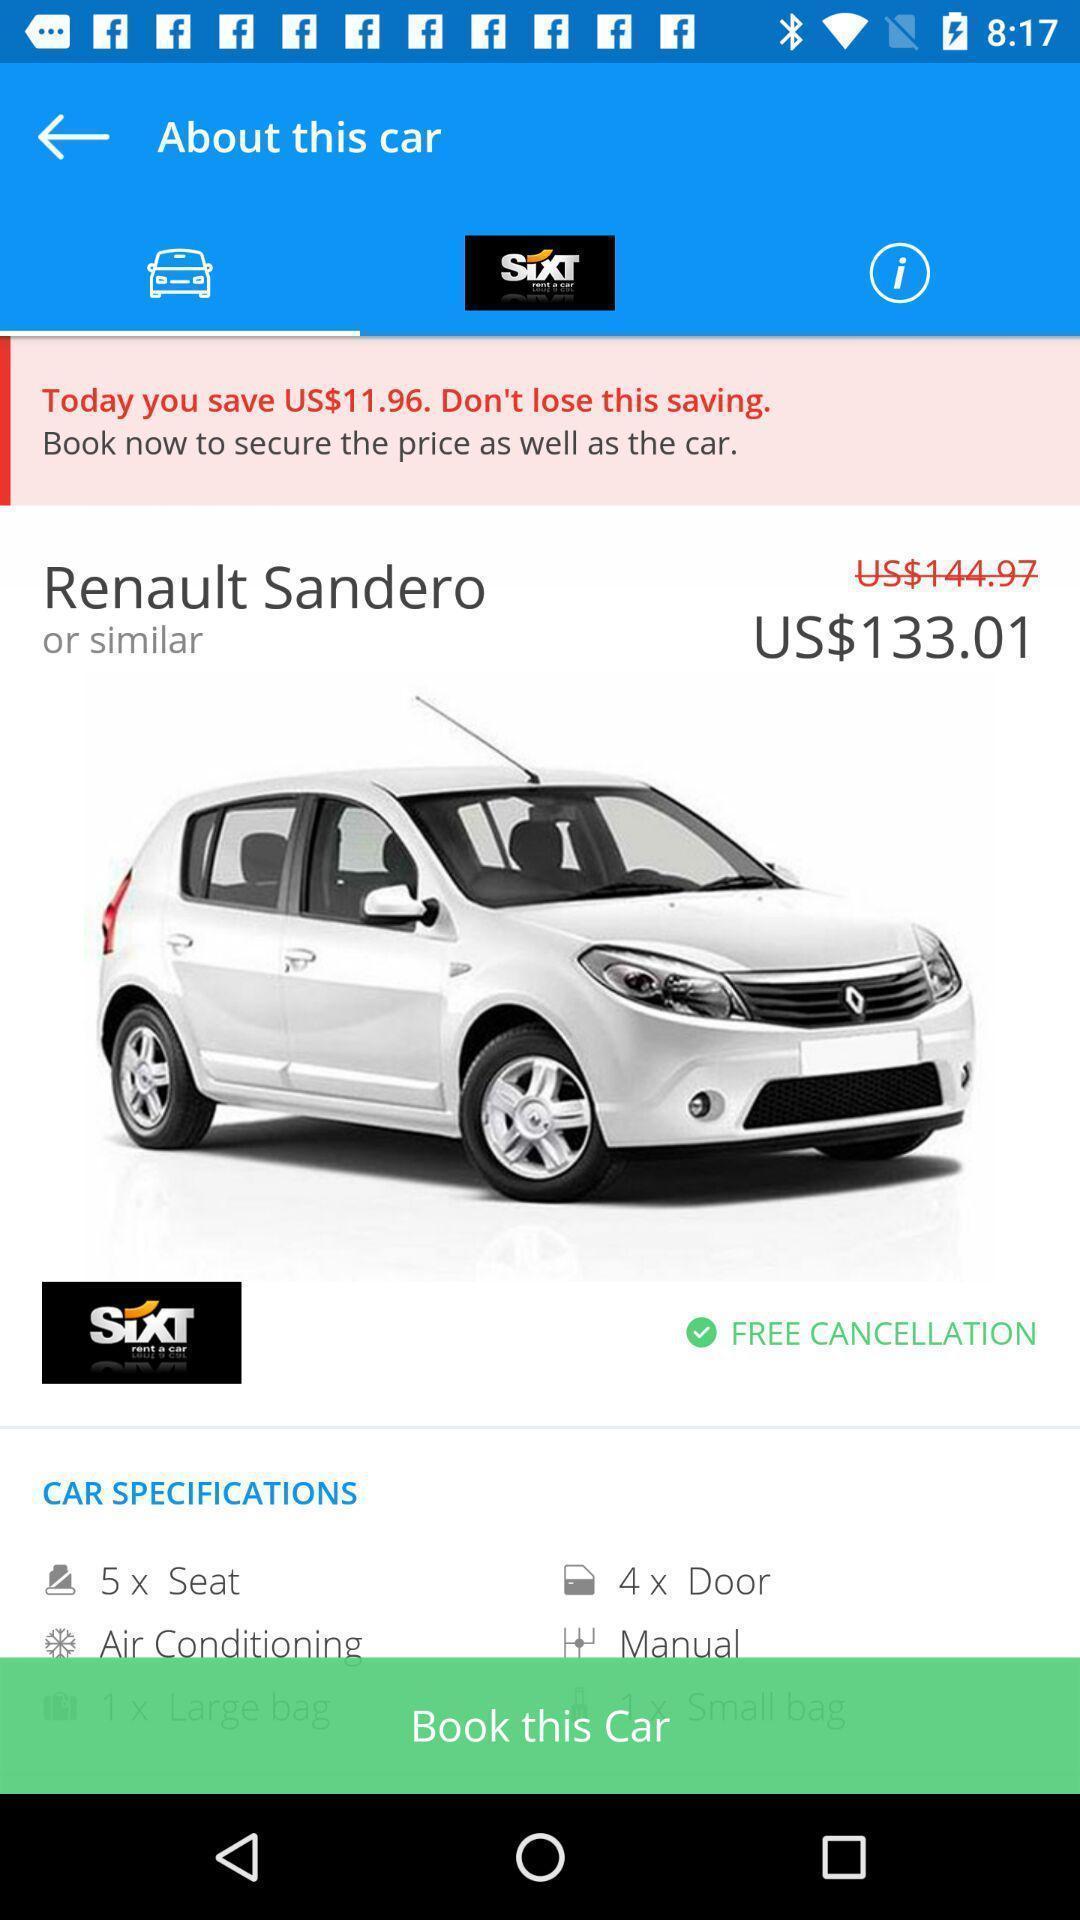Summarize the information in this screenshot. Page displaying the price and details of car to book. 